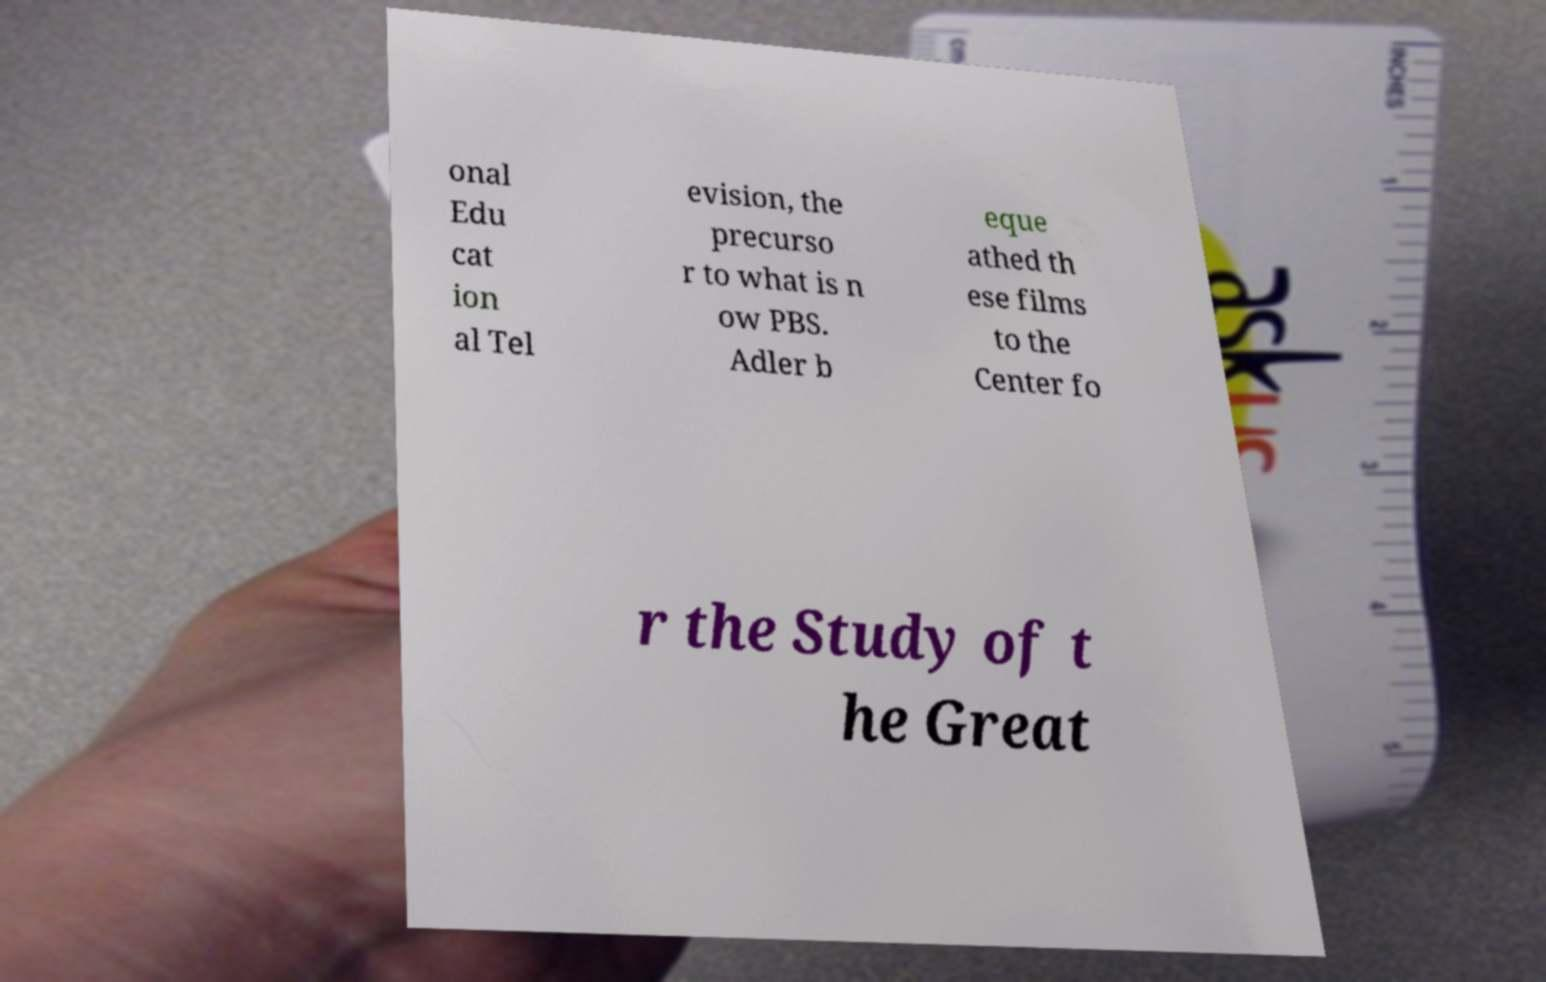I need the written content from this picture converted into text. Can you do that? onal Edu cat ion al Tel evision, the precurso r to what is n ow PBS. Adler b eque athed th ese films to the Center fo r the Study of t he Great 